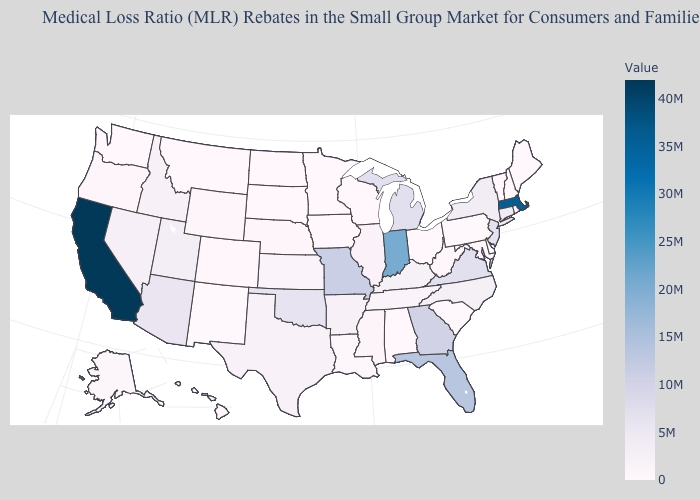Which states have the lowest value in the USA?
Short answer required. Alabama, Delaware, Hawaii, Iowa, Maine, Maryland, Minnesota, Montana, New Hampshire, North Dakota, Rhode Island, South Dakota, Vermont, Washington, Wisconsin. Which states hav the highest value in the Northeast?
Give a very brief answer. Massachusetts. Does California have the highest value in the West?
Write a very short answer. Yes. Which states have the lowest value in the USA?
Write a very short answer. Alabama, Delaware, Hawaii, Iowa, Maine, Maryland, Minnesota, Montana, New Hampshire, North Dakota, Rhode Island, South Dakota, Vermont, Washington, Wisconsin. Which states hav the highest value in the Northeast?
Short answer required. Massachusetts. Does Delaware have the lowest value in the USA?
Concise answer only. Yes. 